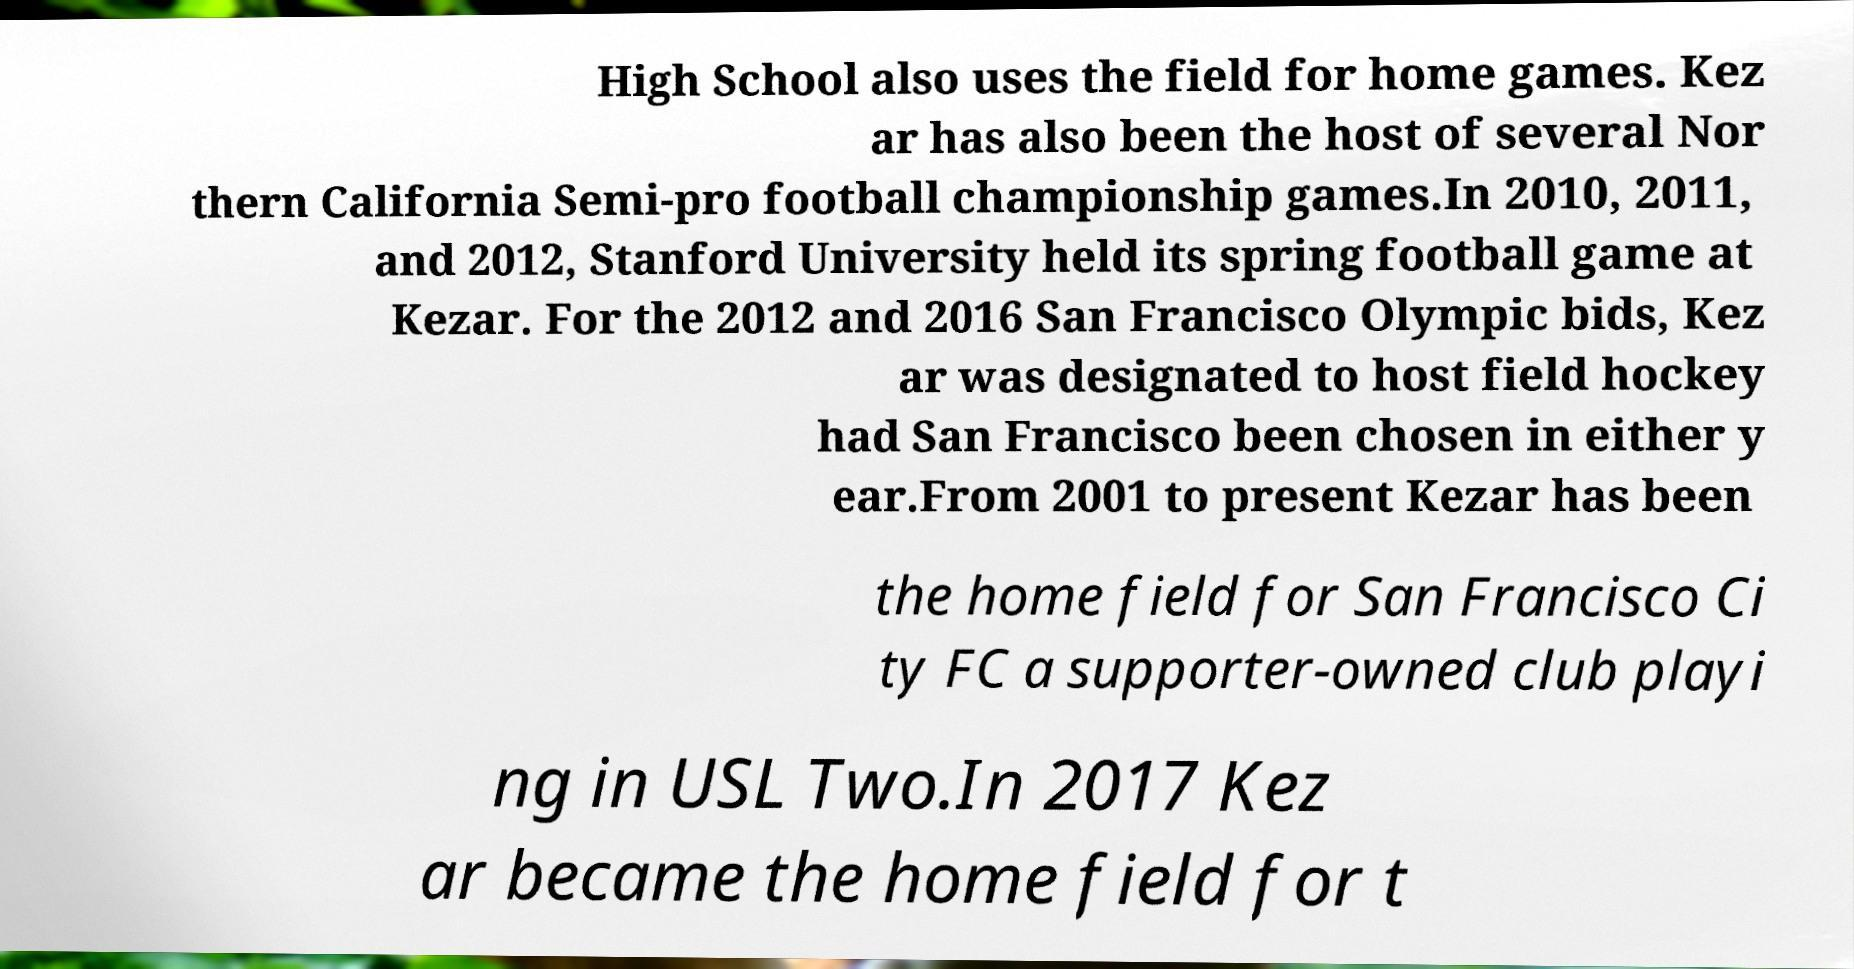There's text embedded in this image that I need extracted. Can you transcribe it verbatim? High School also uses the field for home games. Kez ar has also been the host of several Nor thern California Semi-pro football championship games.In 2010, 2011, and 2012, Stanford University held its spring football game at Kezar. For the 2012 and 2016 San Francisco Olympic bids, Kez ar was designated to host field hockey had San Francisco been chosen in either y ear.From 2001 to present Kezar has been the home field for San Francisco Ci ty FC a supporter-owned club playi ng in USL Two.In 2017 Kez ar became the home field for t 